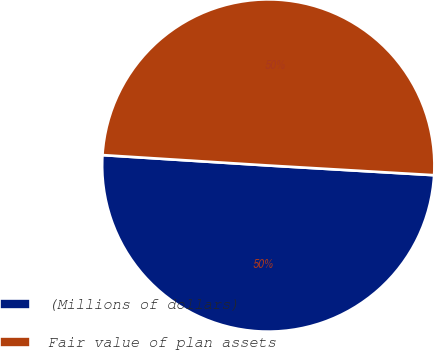<chart> <loc_0><loc_0><loc_500><loc_500><pie_chart><fcel>(Millions of dollars)<fcel>Fair value of plan assets<nl><fcel>50.07%<fcel>49.93%<nl></chart> 